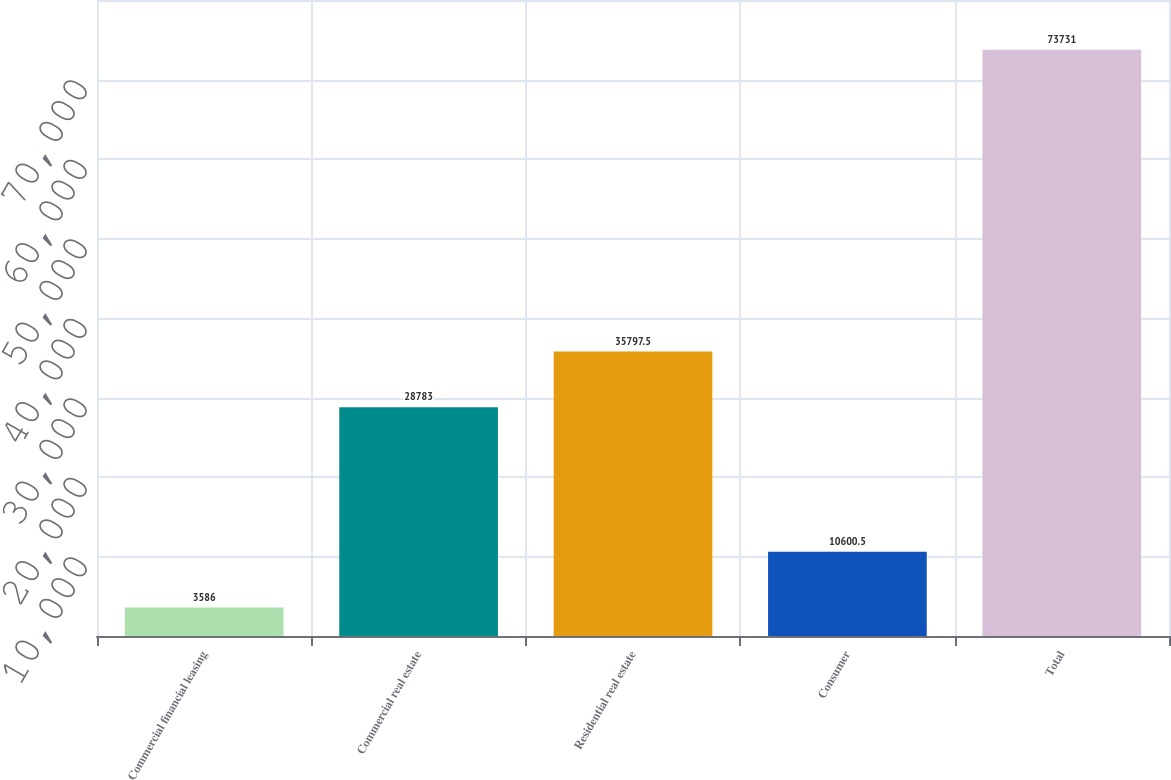<chart> <loc_0><loc_0><loc_500><loc_500><bar_chart><fcel>Commercial financial leasing<fcel>Commercial real estate<fcel>Residential real estate<fcel>Consumer<fcel>Total<nl><fcel>3586<fcel>28783<fcel>35797.5<fcel>10600.5<fcel>73731<nl></chart> 